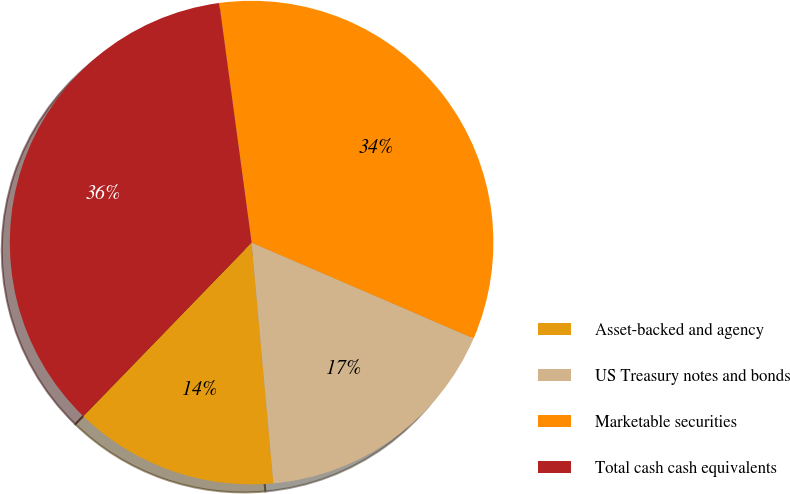Convert chart to OTSL. <chart><loc_0><loc_0><loc_500><loc_500><pie_chart><fcel>Asset-backed and agency<fcel>US Treasury notes and bonds<fcel>Marketable securities<fcel>Total cash cash equivalents<nl><fcel>13.69%<fcel>17.08%<fcel>33.62%<fcel>35.61%<nl></chart> 